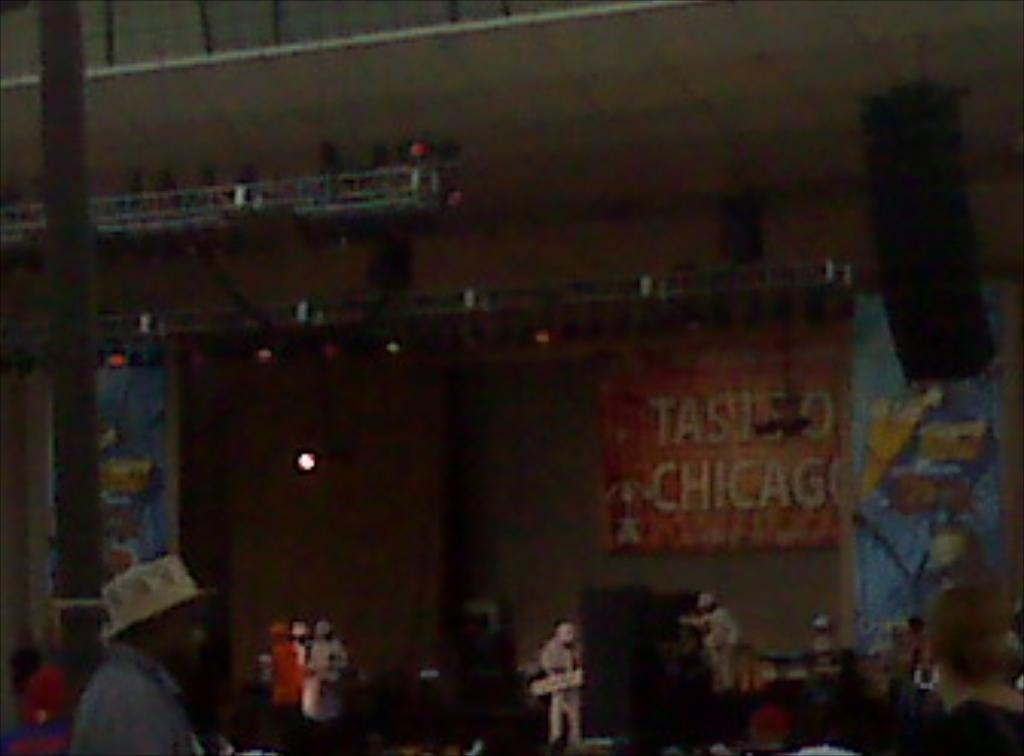How many people are in the image? There is a group of people in the image, but the exact number is not specified. What is one person in the group wearing? One person is wearing a hat. What can be seen in the background of the image? In the background of the image, there are speakers, metal frames with lights, a pole, and banners with some text. What might be used for amplifying sound in the image? The speakers in the background of the image might be used for amplifying sound. What type of balloon is being kicked around by the group of people in the image? There is no balloon present in the image; the group of people is not engaged in any kicking activity. 